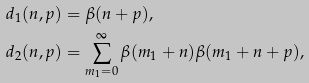Convert formula to latex. <formula><loc_0><loc_0><loc_500><loc_500>d _ { 1 } ( n , p ) & = \beta ( n + p ) , \\ d _ { 2 } ( n , p ) & = \sum _ { m _ { 1 } = 0 } ^ { \infty } \beta ( m _ { 1 } + n ) \beta ( m _ { 1 } + n + p ) ,</formula> 